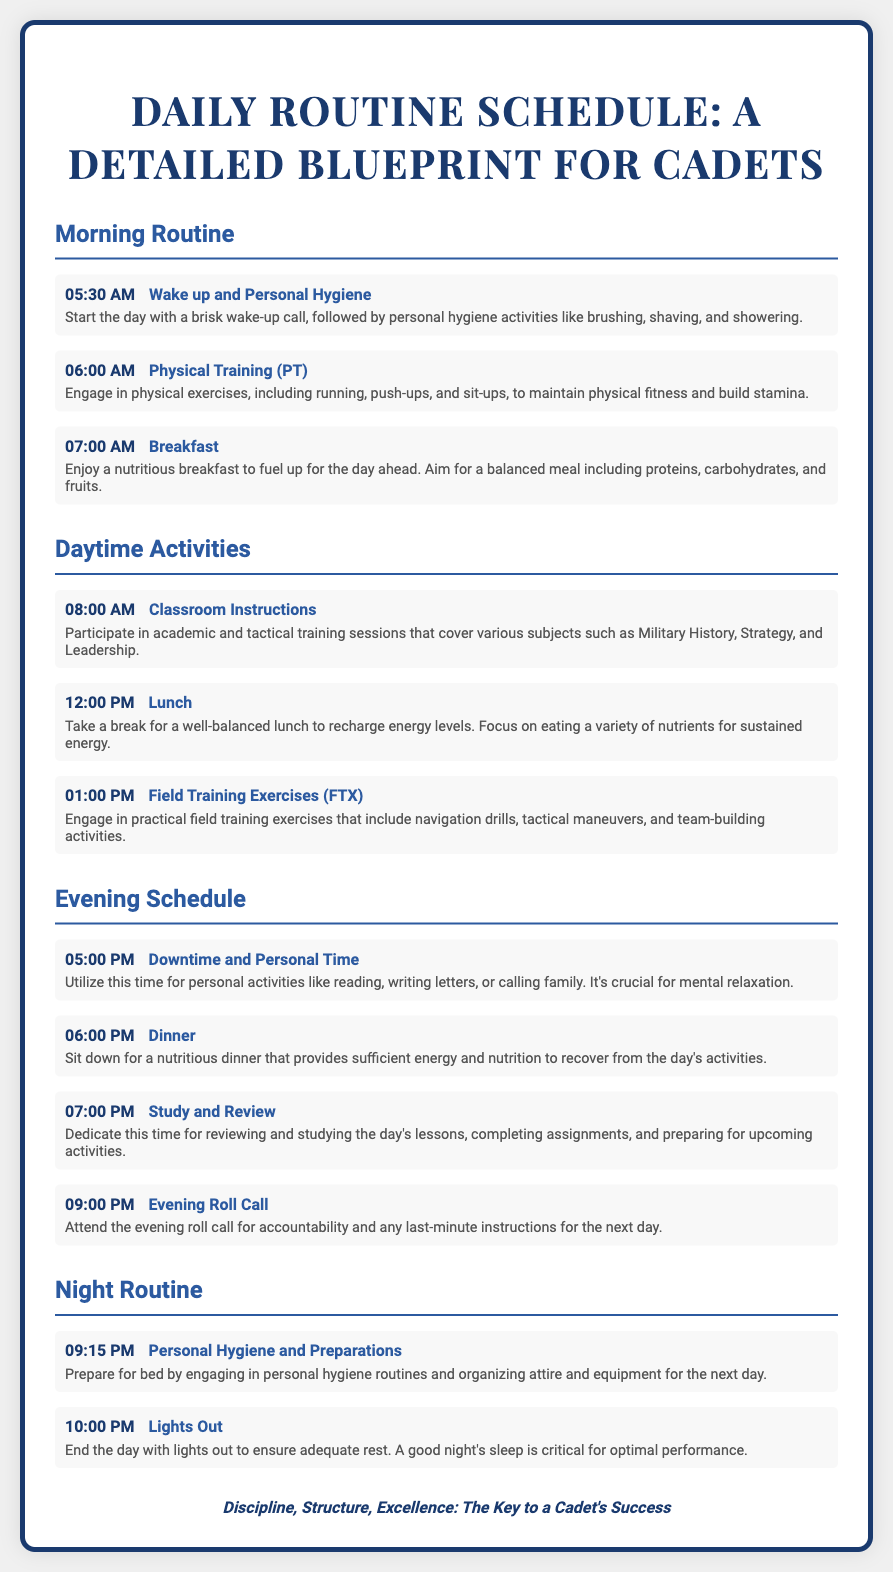What time does the day start for cadets? The day starts at 05:30 AM as indicated in the Morning Routine section.
Answer: 05:30 AM What activity is scheduled immediately after breakfast? The activity after breakfast at 08:00 AM is Classroom Instructions.
Answer: Classroom Instructions How long is the downtime scheduled for? Downtime starts at 05:00 PM and lasts until 06:00 PM, making it one hour long.
Answer: One hour What is the first activity listed in the Evening Schedule? The first activity in the Evening Schedule is Downtime and Personal Time at 05:00 PM.
Answer: Downtime and Personal Time Which meal is scheduled to be eaten after Field Training Exercises? Lunch is scheduled at 12:00 PM, which is after classroom instructions and before Field Training Exercises.
Answer: Lunch What is the main purpose of the night routine according to the schedule? The night routine focuses on preparations for bed and ensuring adequate rest.
Answer: Ensuring adequate rest What is the time for Lights Out? Lights Out is scheduled for 10:00 PM as indicated in the Night Routine section.
Answer: 10:00 PM How does the document encourage success for cadets? It emphasizes Discipline, Structure, and Excellence as key elements for a cadet's success.
Answer: Discipline, Structure, Excellence 